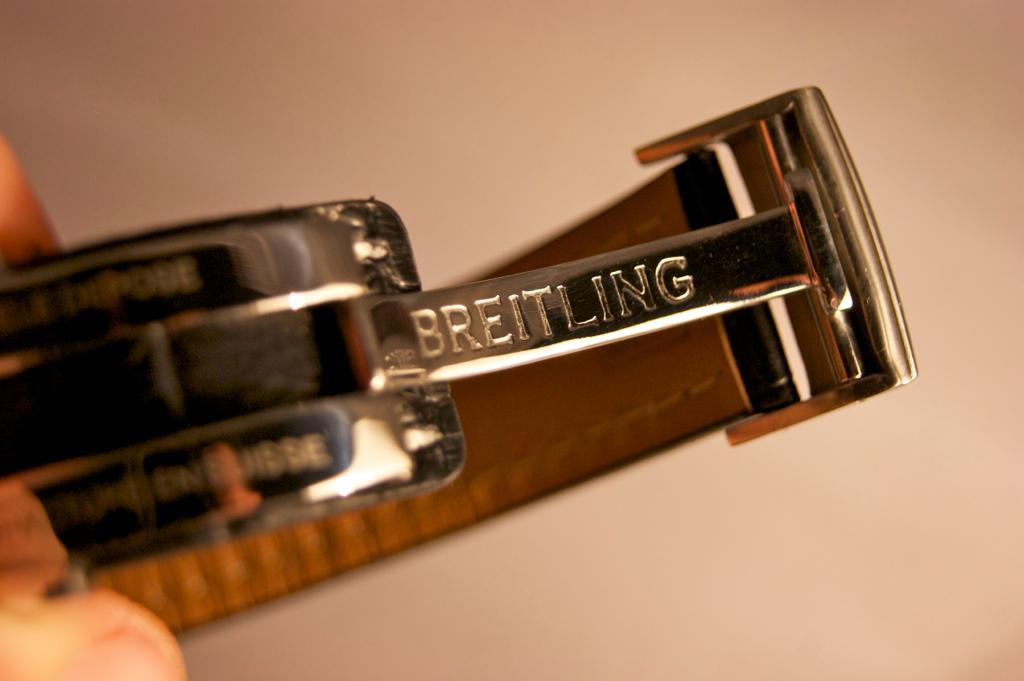What is the main subject of the image? There is a person in the image. What is the person holding in the image? The person is holding a belt. Can you describe the background of the image? The background of the image is blurry. What is the taste of the cream in the image? There is no cream present in the image, so it cannot be tasted. 